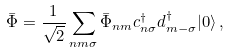Convert formula to latex. <formula><loc_0><loc_0><loc_500><loc_500>\bar { \Phi } = \frac { 1 } { \sqrt { 2 } } \sum _ { n m \sigma } \bar { \Phi } _ { n m } c _ { n \sigma } ^ { \dagger } d _ { m - \sigma } ^ { \dagger } | 0 \rangle \, ,</formula> 